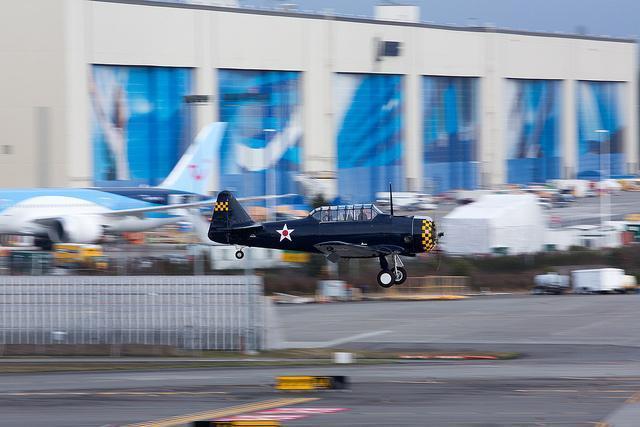How many airplanes can be seen?
Give a very brief answer. 2. 